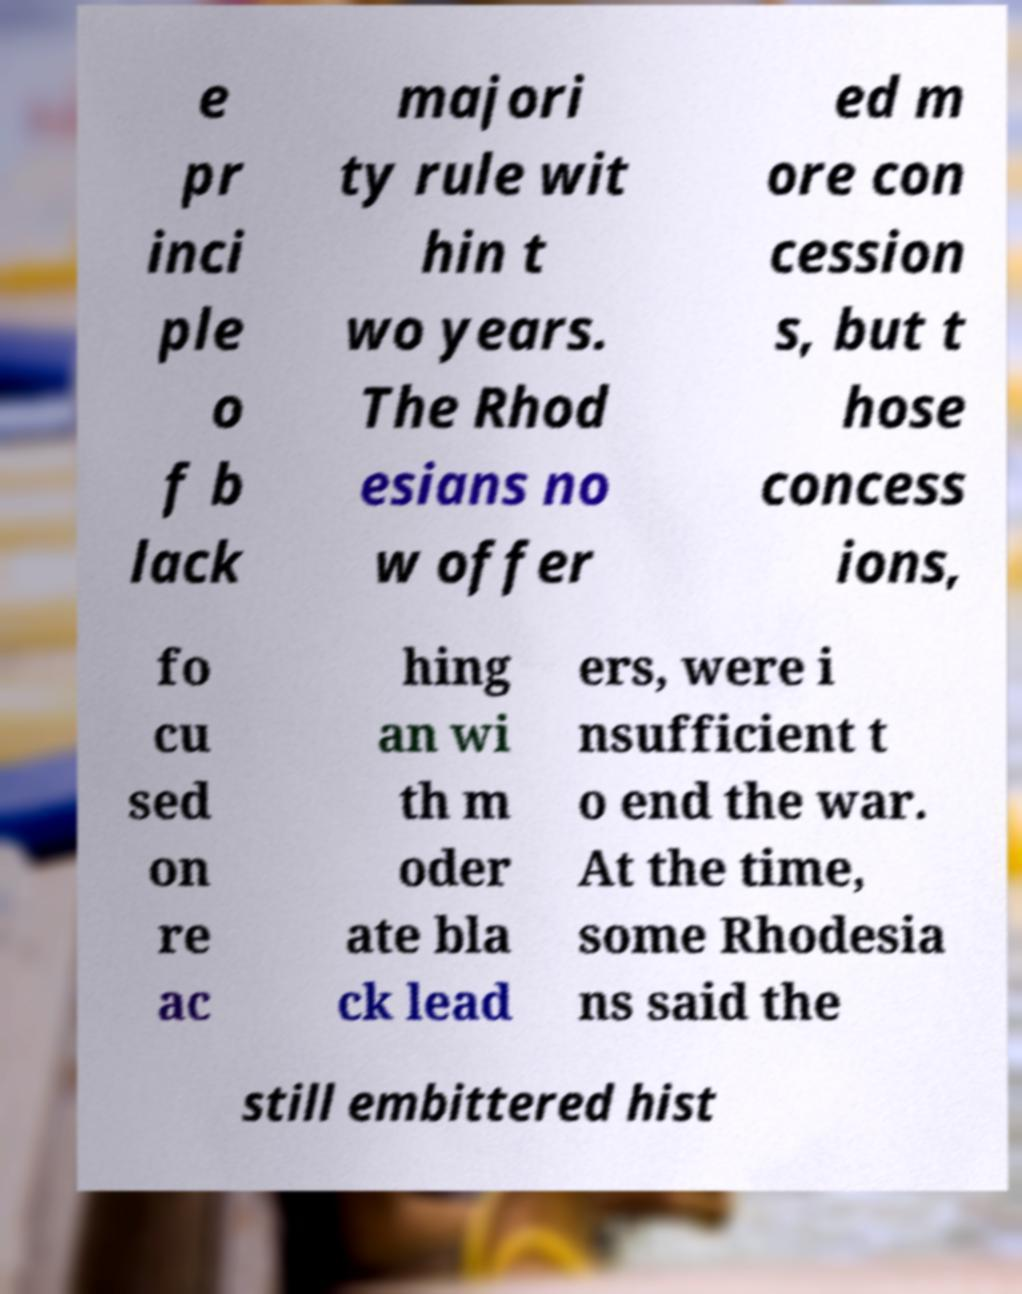For documentation purposes, I need the text within this image transcribed. Could you provide that? e pr inci ple o f b lack majori ty rule wit hin t wo years. The Rhod esians no w offer ed m ore con cession s, but t hose concess ions, fo cu sed on re ac hing an wi th m oder ate bla ck lead ers, were i nsufficient t o end the war. At the time, some Rhodesia ns said the still embittered hist 